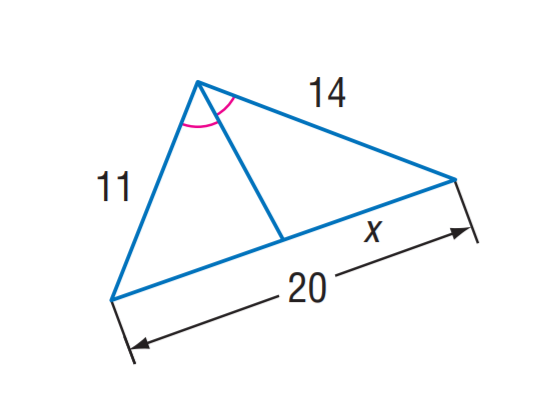Question: Find x.
Choices:
A. 11
B. 11.2
C. 12.4
D. 13.8
Answer with the letter. Answer: B 